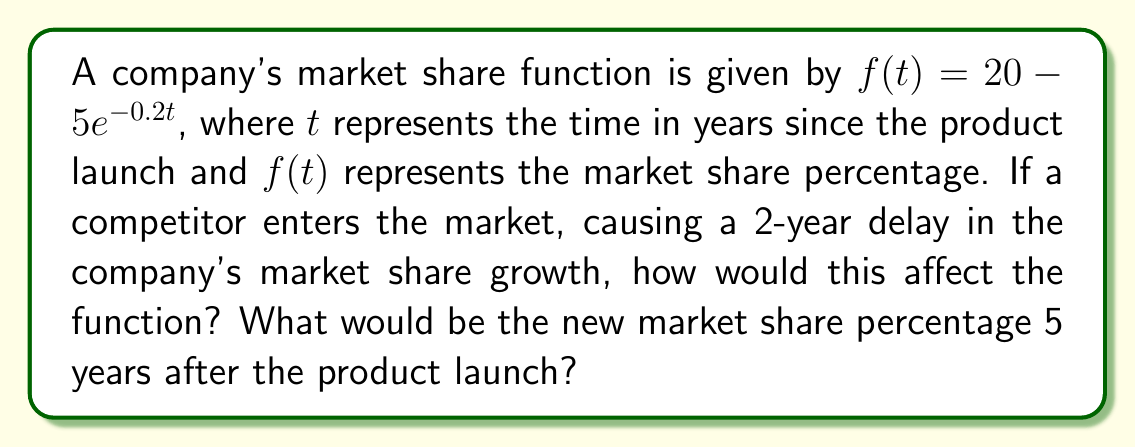Can you answer this question? To solve this problem, we need to understand how translations affect functions and apply this knowledge to the given market share function.

1. The competitor's entry causes a 2-year delay in market share growth. This can be represented as a horizontal translation of the function 2 units to the right.

2. The general form of a horizontal translation is:
   $f(t) \rightarrow f(t-h)$, where $h$ is the number of units of translation to the right.

3. In this case, $h = 2$, so the new function will be:
   $g(t) = 20 - 5e^{-0.2(t-2)}$

4. To find the market share percentage 5 years after the product launch, we need to evaluate $g(5)$:

   $g(5) = 20 - 5e^{-0.2(5-2)}$
   $= 20 - 5e^{-0.2(3)}$
   $= 20 - 5e^{-0.6}$

5. Using a calculator or computer to evaluate this expression:
   $g(5) \approx 20 - 5(0.54881)$
   $\approx 20 - 2.74405$
   $\approx 17.25595$

6. Rounding to two decimal places:
   $g(5) \approx 17.26\%$

This means that 5 years after the product launch, the company's market share would be approximately 17.26%.
Answer: The new market share function is $g(t) = 20 - 5e^{-0.2(t-2)}$, and the market share percentage 5 years after the product launch would be approximately 17.26%. 